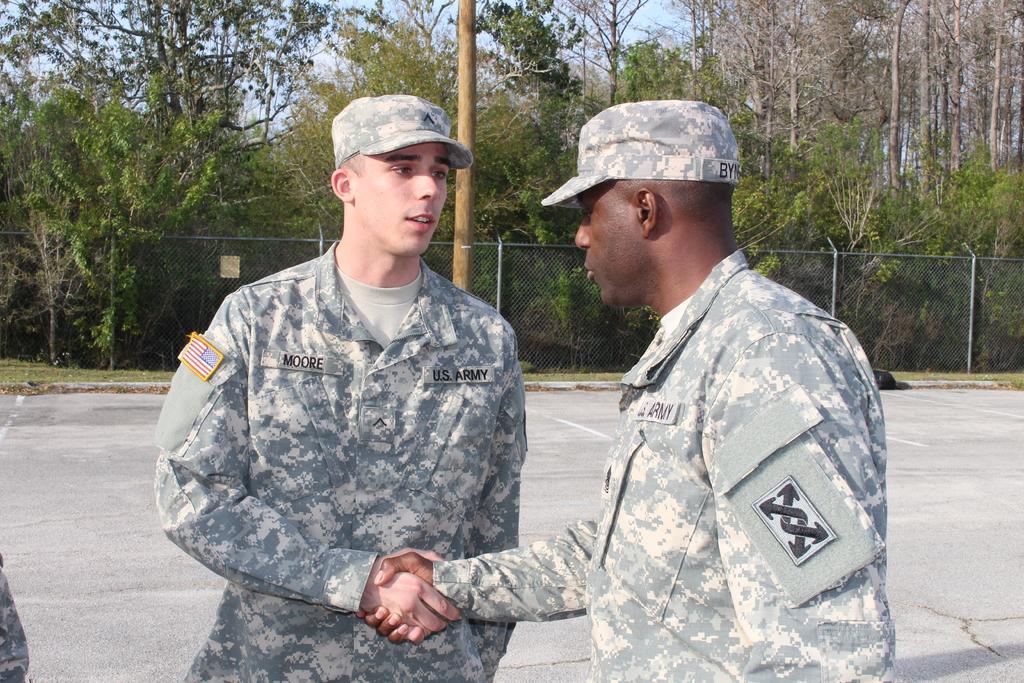Can you describe this image briefly? In this picture we can see two men and in the background we can see the ground, fence, trees and the sky. 